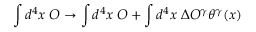<formula> <loc_0><loc_0><loc_500><loc_500>\int d ^ { 4 } x \, O \rightarrow \int d ^ { 4 } x \, O + \int d ^ { 4 } x \, \Delta O ^ { \gamma } \theta ^ { \gamma } ( x )</formula> 